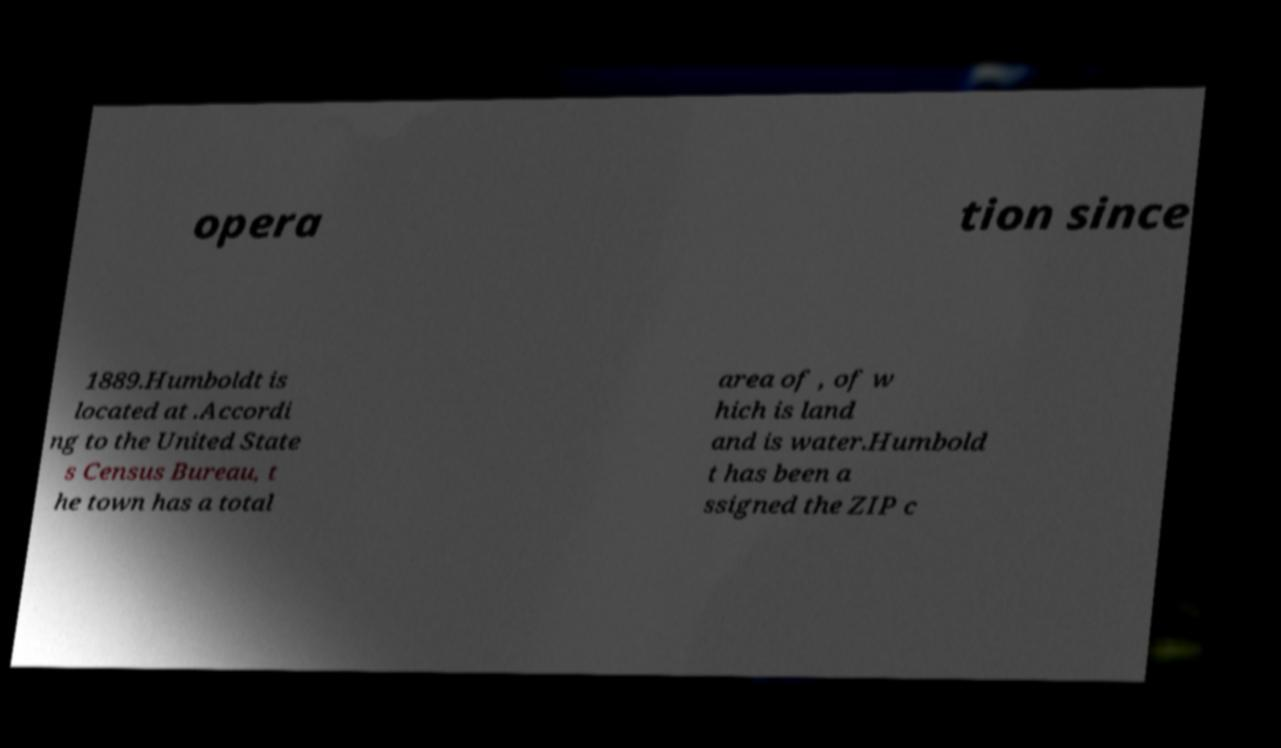I need the written content from this picture converted into text. Can you do that? opera tion since 1889.Humboldt is located at .Accordi ng to the United State s Census Bureau, t he town has a total area of , of w hich is land and is water.Humbold t has been a ssigned the ZIP c 